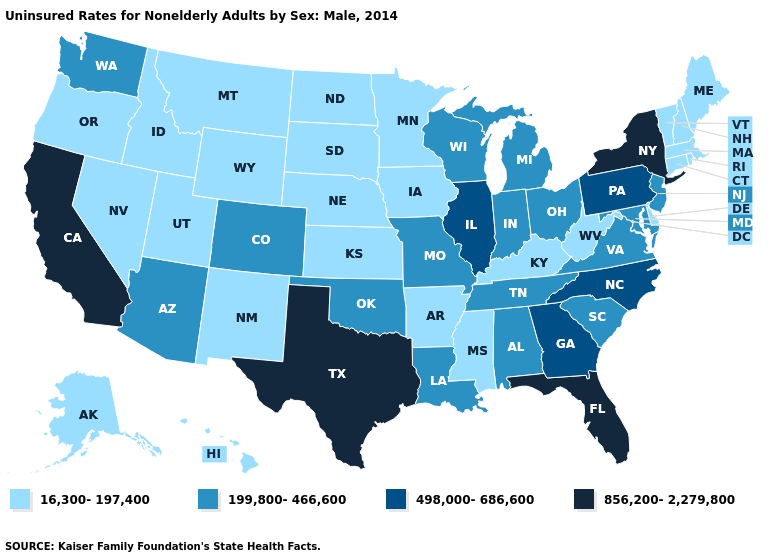What is the value of New Hampshire?
Keep it brief. 16,300-197,400. Does Pennsylvania have a lower value than Maine?
Answer briefly. No. Does the map have missing data?
Be succinct. No. What is the value of Arkansas?
Answer briefly. 16,300-197,400. What is the highest value in the USA?
Answer briefly. 856,200-2,279,800. Name the states that have a value in the range 16,300-197,400?
Answer briefly. Alaska, Arkansas, Connecticut, Delaware, Hawaii, Idaho, Iowa, Kansas, Kentucky, Maine, Massachusetts, Minnesota, Mississippi, Montana, Nebraska, Nevada, New Hampshire, New Mexico, North Dakota, Oregon, Rhode Island, South Dakota, Utah, Vermont, West Virginia, Wyoming. What is the value of Maryland?
Short answer required. 199,800-466,600. Name the states that have a value in the range 856,200-2,279,800?
Write a very short answer. California, Florida, New York, Texas. What is the value of Delaware?
Be succinct. 16,300-197,400. What is the lowest value in the USA?
Answer briefly. 16,300-197,400. Name the states that have a value in the range 16,300-197,400?
Answer briefly. Alaska, Arkansas, Connecticut, Delaware, Hawaii, Idaho, Iowa, Kansas, Kentucky, Maine, Massachusetts, Minnesota, Mississippi, Montana, Nebraska, Nevada, New Hampshire, New Mexico, North Dakota, Oregon, Rhode Island, South Dakota, Utah, Vermont, West Virginia, Wyoming. Does Delaware have a lower value than Missouri?
Be succinct. Yes. Name the states that have a value in the range 498,000-686,600?
Give a very brief answer. Georgia, Illinois, North Carolina, Pennsylvania. What is the value of North Carolina?
Short answer required. 498,000-686,600. What is the value of Colorado?
Answer briefly. 199,800-466,600. 